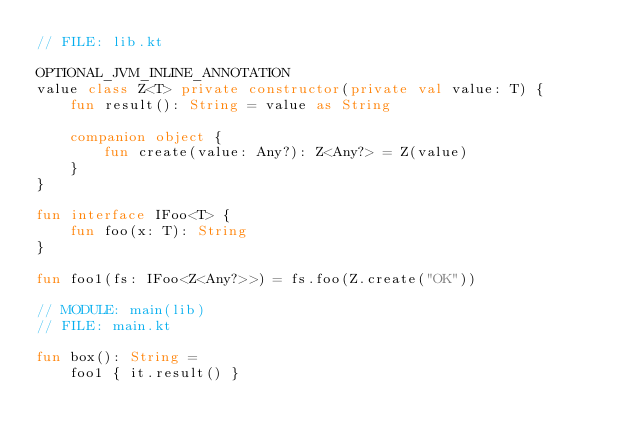Convert code to text. <code><loc_0><loc_0><loc_500><loc_500><_Kotlin_>// FILE: lib.kt

OPTIONAL_JVM_INLINE_ANNOTATION
value class Z<T> private constructor(private val value: T) {
    fun result(): String = value as String

    companion object {
        fun create(value: Any?): Z<Any?> = Z(value)
    }
}

fun interface IFoo<T> {
    fun foo(x: T): String
}

fun foo1(fs: IFoo<Z<Any?>>) = fs.foo(Z.create("OK"))

// MODULE: main(lib)
// FILE: main.kt

fun box(): String =
    foo1 { it.result() }
</code> 